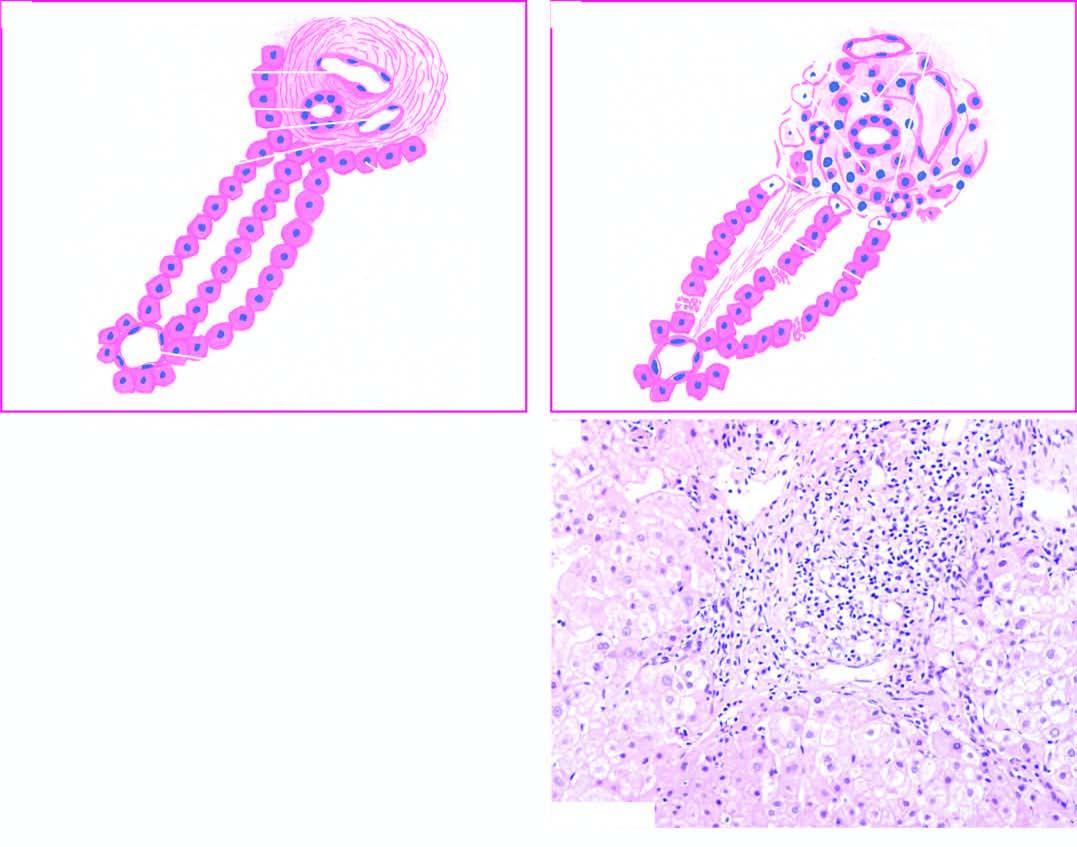s the portal tract expanded due to increased lymphomononuclear inflammatory cells which are seen to breach the limiting plate ie?
Answer the question using a single word or phrase. Yes 